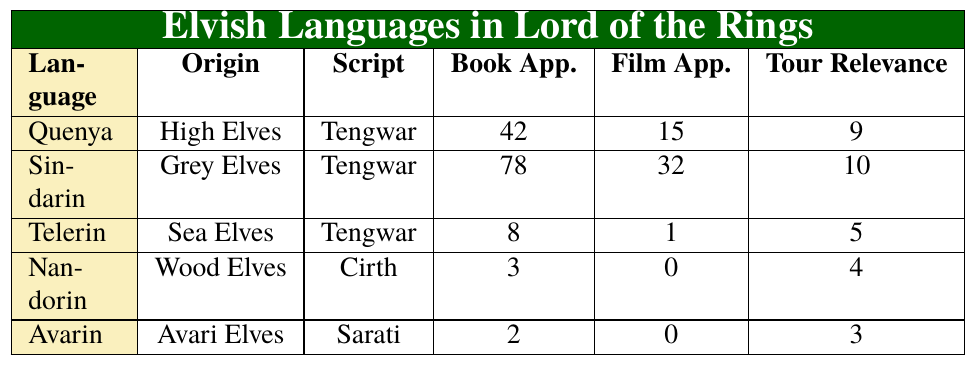What is the primary script used for Quenya? The table lists Quenya and shows that its primary script is Tengwar.
Answer: Tengwar How many book appearances does Sindarin have? By checking the table, Sindarin has 78 book appearances listed.
Answer: 78 Which Elvish language has the least number of film appearances? The table indicates that Avarin and Nandorin both have 0 film appearances, but Avarin also has fewer book appearances.
Answer: Avarin What is the total number of book appearances for all Elvish languages? To find this, sum the book appearances: 42 (Quenya) + 78 (Sindarin) + 8 (Telerin) + 3 (Nandorin) + 2 (Avarin) = 133.
Answer: 133 Which Elvish language has the highest tour relevance? Looking at the tour relevance values, Sindarin has the highest value of 10.
Answer: Sindarin Is Telerin's origin Sea Elves? The table states that the origin of Telerin is indeed listed as Sea Elves.
Answer: True What is the difference in film appearances between Sindarin and Telerin? The table indicates Sindarin has 32 film appearances and Telerin has 1. The difference is 32 - 1 = 31.
Answer: 31 Which language has the highest number of grammatical cases? Checking the grammatical cases listed, Quenya has 10 cases, which is the highest.
Answer: Quenya What would be the average tour relevance of Elvish languages? Calculate the average by summing the tour relevance values: 9 (Quenya) + 10 (Sindarin) + 5 (Telerin) + 4 (Nandorin) + 3 (Avarin) = 31, then divide by 5: 31 / 5 = 6.2.
Answer: 6.2 Does any language have more film appearances than book appearances? Upon examining the table, Sindarin has more film appearances (32) than book appearances (78), which is false when comparing both; no language meets this criterion.
Answer: False 